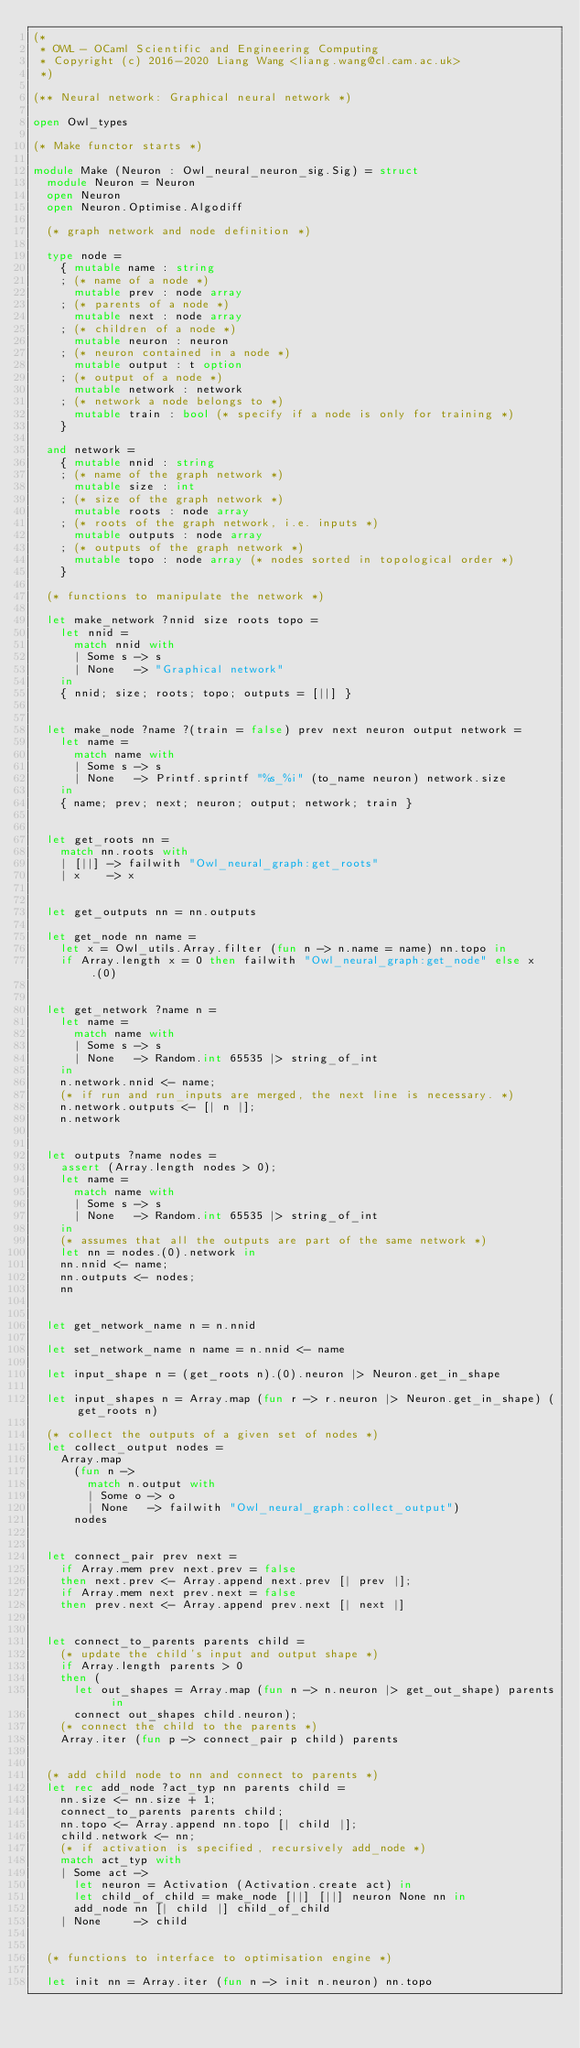<code> <loc_0><loc_0><loc_500><loc_500><_OCaml_>(*
 * OWL - OCaml Scientific and Engineering Computing
 * Copyright (c) 2016-2020 Liang Wang <liang.wang@cl.cam.ac.uk>
 *)

(** Neural network: Graphical neural network *)

open Owl_types

(* Make functor starts *)

module Make (Neuron : Owl_neural_neuron_sig.Sig) = struct
  module Neuron = Neuron
  open Neuron
  open Neuron.Optimise.Algodiff

  (* graph network and node definition *)

  type node =
    { mutable name : string
    ; (* name of a node *)
      mutable prev : node array
    ; (* parents of a node *)
      mutable next : node array
    ; (* children of a node *)
      mutable neuron : neuron
    ; (* neuron contained in a node *)
      mutable output : t option
    ; (* output of a node *)
      mutable network : network
    ; (* network a node belongs to *)
      mutable train : bool (* specify if a node is only for training *)
    }

  and network =
    { mutable nnid : string
    ; (* name of the graph network *)
      mutable size : int
    ; (* size of the graph network *)
      mutable roots : node array
    ; (* roots of the graph network, i.e. inputs *)
      mutable outputs : node array
    ; (* outputs of the graph network *)
      mutable topo : node array (* nodes sorted in topological order *)
    }

  (* functions to manipulate the network *)

  let make_network ?nnid size roots topo =
    let nnid =
      match nnid with
      | Some s -> s
      | None   -> "Graphical network"
    in
    { nnid; size; roots; topo; outputs = [||] }


  let make_node ?name ?(train = false) prev next neuron output network =
    let name =
      match name with
      | Some s -> s
      | None   -> Printf.sprintf "%s_%i" (to_name neuron) network.size
    in
    { name; prev; next; neuron; output; network; train }


  let get_roots nn =
    match nn.roots with
    | [||] -> failwith "Owl_neural_graph:get_roots"
    | x    -> x


  let get_outputs nn = nn.outputs

  let get_node nn name =
    let x = Owl_utils.Array.filter (fun n -> n.name = name) nn.topo in
    if Array.length x = 0 then failwith "Owl_neural_graph:get_node" else x.(0)


  let get_network ?name n =
    let name =
      match name with
      | Some s -> s
      | None   -> Random.int 65535 |> string_of_int
    in
    n.network.nnid <- name;
    (* if run and run_inputs are merged, the next line is necessary. *)
    n.network.outputs <- [| n |];
    n.network


  let outputs ?name nodes =
    assert (Array.length nodes > 0);
    let name =
      match name with
      | Some s -> s
      | None   -> Random.int 65535 |> string_of_int
    in
    (* assumes that all the outputs are part of the same network *)
    let nn = nodes.(0).network in
    nn.nnid <- name;
    nn.outputs <- nodes;
    nn


  let get_network_name n = n.nnid

  let set_network_name n name = n.nnid <- name

  let input_shape n = (get_roots n).(0).neuron |> Neuron.get_in_shape

  let input_shapes n = Array.map (fun r -> r.neuron |> Neuron.get_in_shape) (get_roots n)

  (* collect the outputs of a given set of nodes *)
  let collect_output nodes =
    Array.map
      (fun n ->
        match n.output with
        | Some o -> o
        | None   -> failwith "Owl_neural_graph:collect_output")
      nodes


  let connect_pair prev next =
    if Array.mem prev next.prev = false
    then next.prev <- Array.append next.prev [| prev |];
    if Array.mem next prev.next = false
    then prev.next <- Array.append prev.next [| next |]


  let connect_to_parents parents child =
    (* update the child's input and output shape *)
    if Array.length parents > 0
    then (
      let out_shapes = Array.map (fun n -> n.neuron |> get_out_shape) parents in
      connect out_shapes child.neuron);
    (* connect the child to the parents *)
    Array.iter (fun p -> connect_pair p child) parents


  (* add child node to nn and connect to parents *)
  let rec add_node ?act_typ nn parents child =
    nn.size <- nn.size + 1;
    connect_to_parents parents child;
    nn.topo <- Array.append nn.topo [| child |];
    child.network <- nn;
    (* if activation is specified, recursively add_node *)
    match act_typ with
    | Some act ->
      let neuron = Activation (Activation.create act) in
      let child_of_child = make_node [||] [||] neuron None nn in
      add_node nn [| child |] child_of_child
    | None     -> child


  (* functions to interface to optimisation engine *)

  let init nn = Array.iter (fun n -> init n.neuron) nn.topo
</code> 